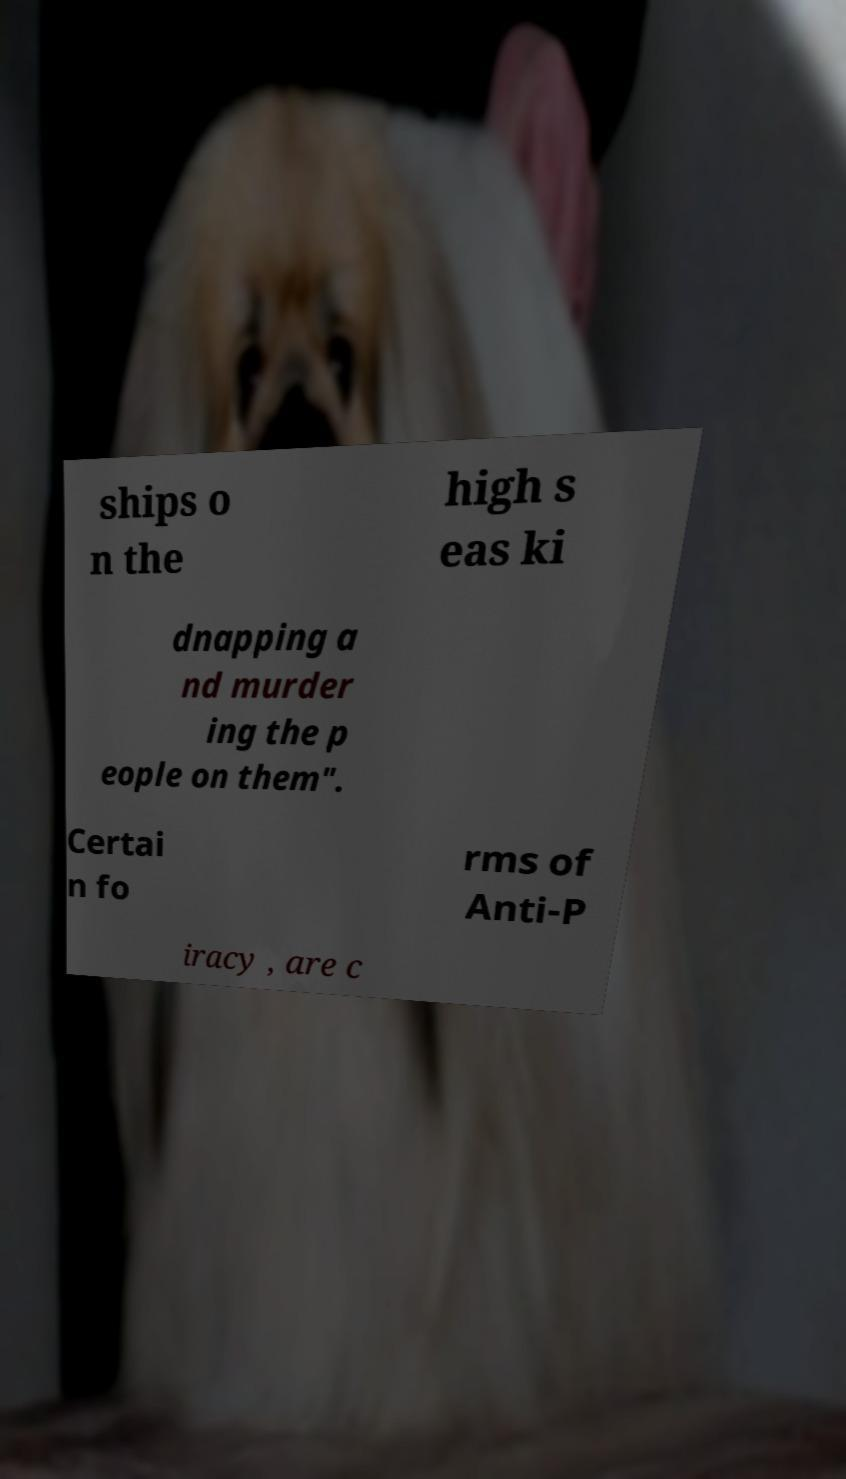I need the written content from this picture converted into text. Can you do that? ships o n the high s eas ki dnapping a nd murder ing the p eople on them". Certai n fo rms of Anti-P iracy , are c 